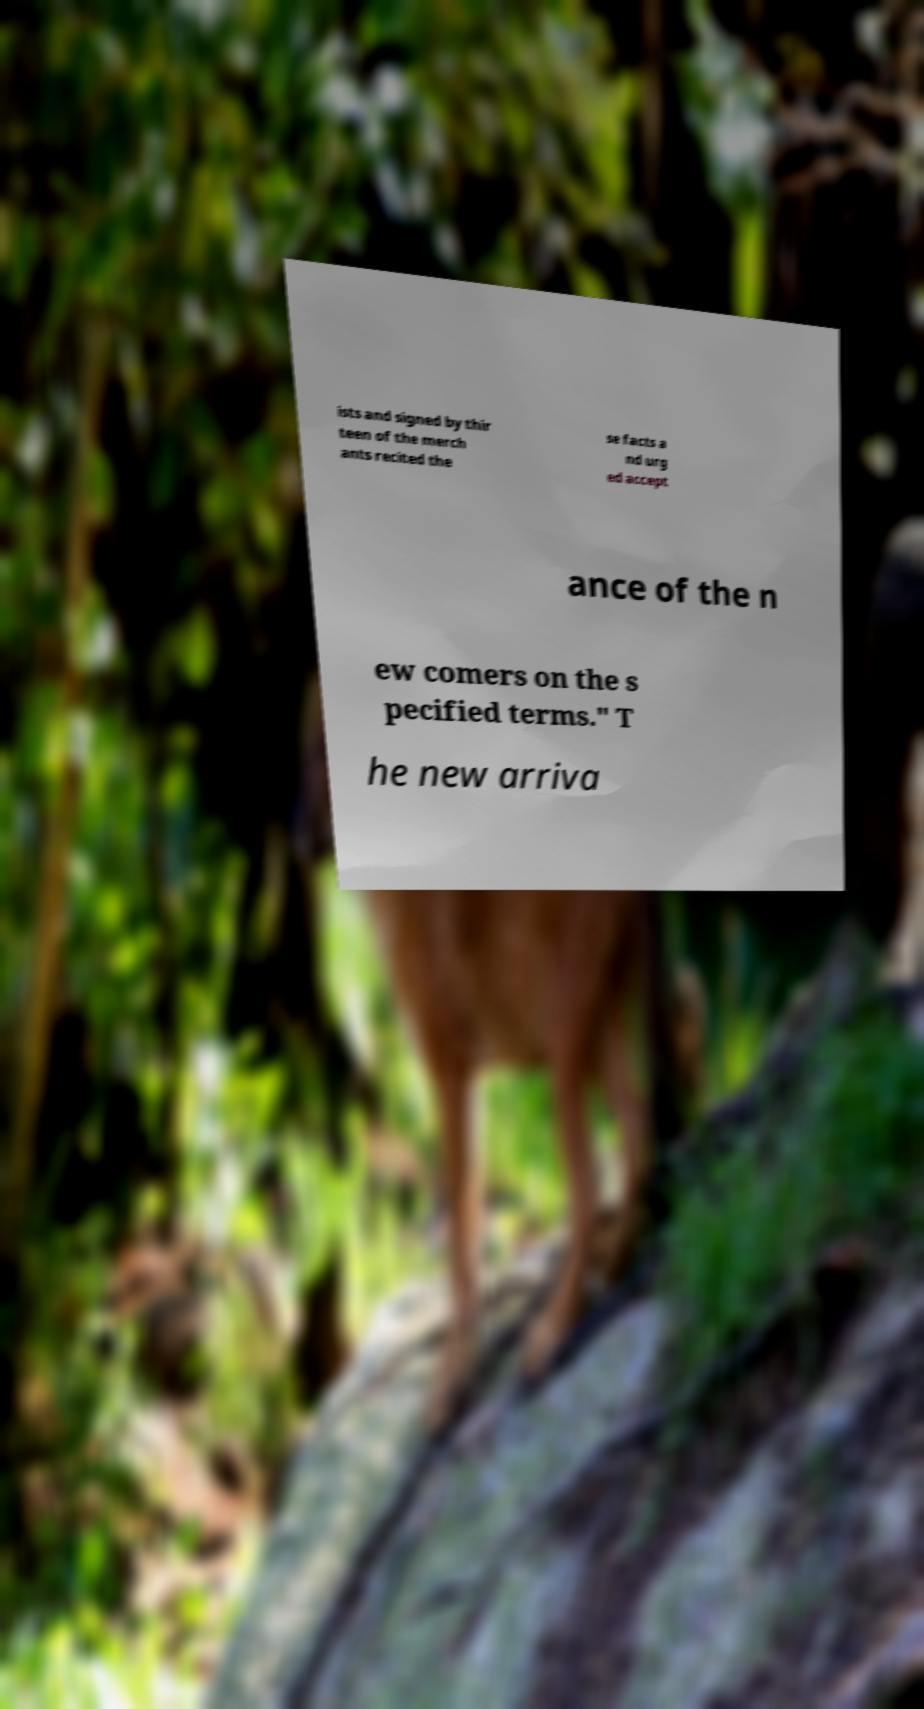Please identify and transcribe the text found in this image. ists and signed by thir teen of the merch ants recited the se facts a nd urg ed accept ance of the n ew comers on the s pecified terms." T he new arriva 